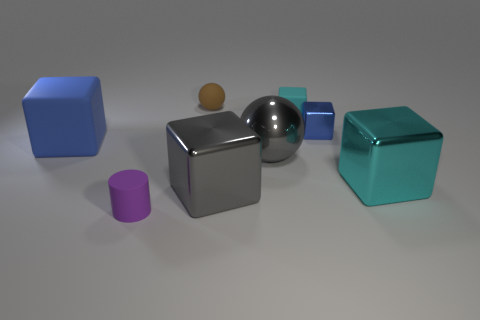Subtract all big gray blocks. How many blocks are left? 4 Add 1 gray blocks. How many objects exist? 9 Subtract all gray cubes. How many cubes are left? 4 Subtract all brown blocks. Subtract all gray cylinders. How many blocks are left? 5 Subtract all blocks. How many objects are left? 3 Subtract 0 purple balls. How many objects are left? 8 Subtract all big gray spheres. Subtract all metal cubes. How many objects are left? 4 Add 5 tiny metal blocks. How many tiny metal blocks are left? 6 Add 6 large objects. How many large objects exist? 10 